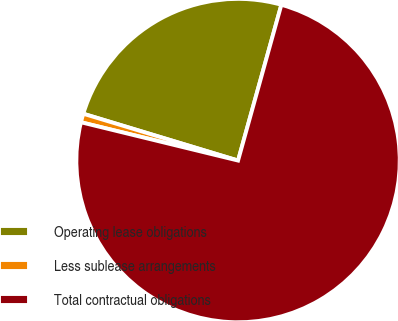Convert chart to OTSL. <chart><loc_0><loc_0><loc_500><loc_500><pie_chart><fcel>Operating lease obligations<fcel>Less sublease arrangements<fcel>Total contractual obligations<nl><fcel>24.64%<fcel>0.87%<fcel>74.49%<nl></chart> 